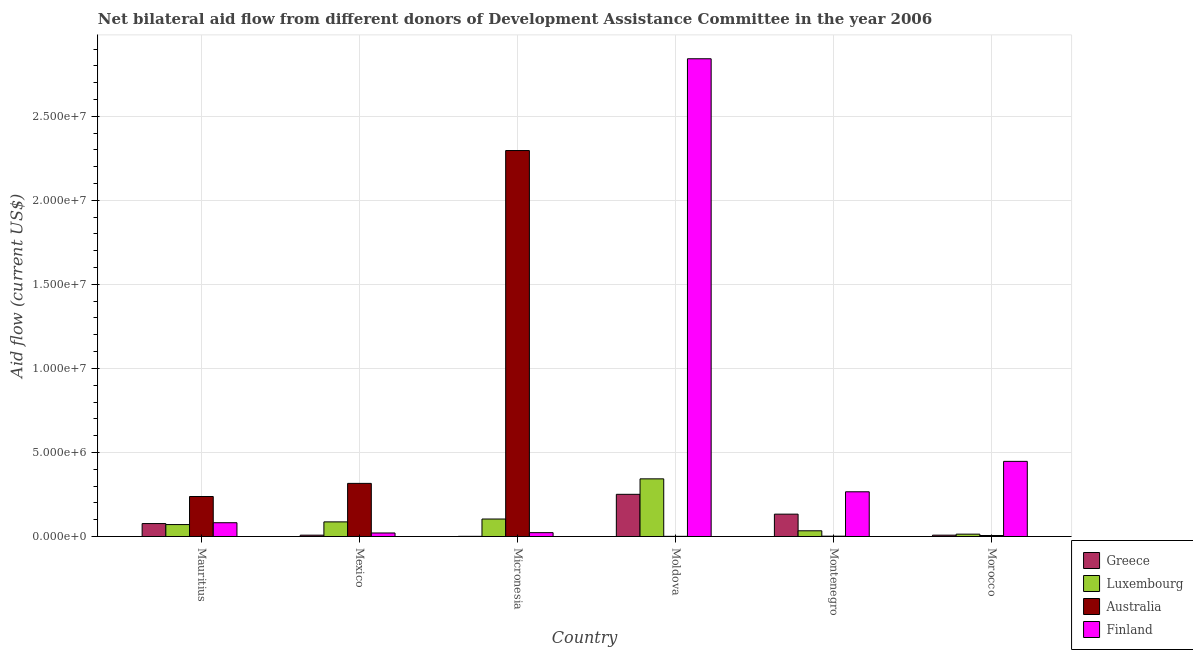How many bars are there on the 4th tick from the left?
Provide a succinct answer. 4. How many bars are there on the 6th tick from the right?
Keep it short and to the point. 4. What is the label of the 5th group of bars from the left?
Provide a short and direct response. Montenegro. In how many cases, is the number of bars for a given country not equal to the number of legend labels?
Give a very brief answer. 0. What is the amount of aid given by greece in Mexico?
Offer a very short reply. 8.00e+04. Across all countries, what is the maximum amount of aid given by luxembourg?
Provide a short and direct response. 3.43e+06. Across all countries, what is the minimum amount of aid given by finland?
Your answer should be very brief. 2.10e+05. In which country was the amount of aid given by luxembourg maximum?
Offer a terse response. Moldova. In which country was the amount of aid given by luxembourg minimum?
Offer a terse response. Morocco. What is the total amount of aid given by finland in the graph?
Your response must be concise. 3.68e+07. What is the difference between the amount of aid given by australia in Moldova and that in Montenegro?
Make the answer very short. -10000. What is the difference between the amount of aid given by finland in Morocco and the amount of aid given by australia in Mauritius?
Your answer should be very brief. 2.09e+06. What is the average amount of aid given by finland per country?
Provide a succinct answer. 6.14e+06. What is the difference between the amount of aid given by finland and amount of aid given by australia in Moldova?
Your answer should be compact. 2.84e+07. What is the ratio of the amount of aid given by luxembourg in Micronesia to that in Morocco?
Your answer should be compact. 7.43. What is the difference between the highest and the second highest amount of aid given by luxembourg?
Provide a succinct answer. 2.39e+06. What is the difference between the highest and the lowest amount of aid given by greece?
Provide a short and direct response. 2.50e+06. In how many countries, is the amount of aid given by finland greater than the average amount of aid given by finland taken over all countries?
Provide a short and direct response. 1. Is the sum of the amount of aid given by australia in Mauritius and Mexico greater than the maximum amount of aid given by greece across all countries?
Give a very brief answer. Yes. What does the 3rd bar from the right in Montenegro represents?
Your answer should be very brief. Luxembourg. Is it the case that in every country, the sum of the amount of aid given by greece and amount of aid given by luxembourg is greater than the amount of aid given by australia?
Offer a terse response. No. How many bars are there?
Your answer should be compact. 24. What is the difference between two consecutive major ticks on the Y-axis?
Your answer should be compact. 5.00e+06. How many legend labels are there?
Your answer should be very brief. 4. What is the title of the graph?
Ensure brevity in your answer.  Net bilateral aid flow from different donors of Development Assistance Committee in the year 2006. Does "Manufacturing" appear as one of the legend labels in the graph?
Offer a very short reply. No. What is the Aid flow (current US$) of Greece in Mauritius?
Offer a terse response. 7.70e+05. What is the Aid flow (current US$) of Luxembourg in Mauritius?
Provide a short and direct response. 7.10e+05. What is the Aid flow (current US$) in Australia in Mauritius?
Your answer should be compact. 2.38e+06. What is the Aid flow (current US$) of Finland in Mauritius?
Provide a succinct answer. 8.20e+05. What is the Aid flow (current US$) in Luxembourg in Mexico?
Offer a terse response. 8.70e+05. What is the Aid flow (current US$) of Australia in Mexico?
Offer a terse response. 3.16e+06. What is the Aid flow (current US$) of Greece in Micronesia?
Make the answer very short. 10000. What is the Aid flow (current US$) of Luxembourg in Micronesia?
Your answer should be compact. 1.04e+06. What is the Aid flow (current US$) of Australia in Micronesia?
Your answer should be very brief. 2.30e+07. What is the Aid flow (current US$) in Greece in Moldova?
Offer a terse response. 2.51e+06. What is the Aid flow (current US$) of Luxembourg in Moldova?
Keep it short and to the point. 3.43e+06. What is the Aid flow (current US$) of Finland in Moldova?
Give a very brief answer. 2.84e+07. What is the Aid flow (current US$) in Greece in Montenegro?
Ensure brevity in your answer.  1.33e+06. What is the Aid flow (current US$) in Finland in Montenegro?
Offer a terse response. 2.66e+06. What is the Aid flow (current US$) of Greece in Morocco?
Offer a terse response. 8.00e+04. What is the Aid flow (current US$) of Finland in Morocco?
Provide a short and direct response. 4.47e+06. Across all countries, what is the maximum Aid flow (current US$) of Greece?
Offer a terse response. 2.51e+06. Across all countries, what is the maximum Aid flow (current US$) of Luxembourg?
Keep it short and to the point. 3.43e+06. Across all countries, what is the maximum Aid flow (current US$) in Australia?
Ensure brevity in your answer.  2.30e+07. Across all countries, what is the maximum Aid flow (current US$) in Finland?
Your answer should be very brief. 2.84e+07. Across all countries, what is the minimum Aid flow (current US$) of Australia?
Your response must be concise. 10000. What is the total Aid flow (current US$) in Greece in the graph?
Make the answer very short. 4.78e+06. What is the total Aid flow (current US$) in Luxembourg in the graph?
Provide a succinct answer. 6.53e+06. What is the total Aid flow (current US$) of Australia in the graph?
Give a very brief answer. 2.86e+07. What is the total Aid flow (current US$) of Finland in the graph?
Offer a terse response. 3.68e+07. What is the difference between the Aid flow (current US$) of Greece in Mauritius and that in Mexico?
Your answer should be compact. 6.90e+05. What is the difference between the Aid flow (current US$) of Australia in Mauritius and that in Mexico?
Your answer should be very brief. -7.80e+05. What is the difference between the Aid flow (current US$) of Finland in Mauritius and that in Mexico?
Provide a short and direct response. 6.10e+05. What is the difference between the Aid flow (current US$) of Greece in Mauritius and that in Micronesia?
Provide a short and direct response. 7.60e+05. What is the difference between the Aid flow (current US$) of Luxembourg in Mauritius and that in Micronesia?
Your answer should be compact. -3.30e+05. What is the difference between the Aid flow (current US$) in Australia in Mauritius and that in Micronesia?
Ensure brevity in your answer.  -2.06e+07. What is the difference between the Aid flow (current US$) in Finland in Mauritius and that in Micronesia?
Offer a very short reply. 5.90e+05. What is the difference between the Aid flow (current US$) in Greece in Mauritius and that in Moldova?
Offer a very short reply. -1.74e+06. What is the difference between the Aid flow (current US$) of Luxembourg in Mauritius and that in Moldova?
Make the answer very short. -2.72e+06. What is the difference between the Aid flow (current US$) of Australia in Mauritius and that in Moldova?
Provide a short and direct response. 2.37e+06. What is the difference between the Aid flow (current US$) in Finland in Mauritius and that in Moldova?
Your response must be concise. -2.76e+07. What is the difference between the Aid flow (current US$) of Greece in Mauritius and that in Montenegro?
Your answer should be very brief. -5.60e+05. What is the difference between the Aid flow (current US$) in Luxembourg in Mauritius and that in Montenegro?
Your response must be concise. 3.70e+05. What is the difference between the Aid flow (current US$) in Australia in Mauritius and that in Montenegro?
Provide a short and direct response. 2.36e+06. What is the difference between the Aid flow (current US$) of Finland in Mauritius and that in Montenegro?
Keep it short and to the point. -1.84e+06. What is the difference between the Aid flow (current US$) in Greece in Mauritius and that in Morocco?
Provide a short and direct response. 6.90e+05. What is the difference between the Aid flow (current US$) in Luxembourg in Mauritius and that in Morocco?
Your answer should be compact. 5.70e+05. What is the difference between the Aid flow (current US$) in Australia in Mauritius and that in Morocco?
Offer a terse response. 2.32e+06. What is the difference between the Aid flow (current US$) of Finland in Mauritius and that in Morocco?
Offer a terse response. -3.65e+06. What is the difference between the Aid flow (current US$) in Luxembourg in Mexico and that in Micronesia?
Offer a terse response. -1.70e+05. What is the difference between the Aid flow (current US$) in Australia in Mexico and that in Micronesia?
Give a very brief answer. -1.98e+07. What is the difference between the Aid flow (current US$) of Finland in Mexico and that in Micronesia?
Your response must be concise. -2.00e+04. What is the difference between the Aid flow (current US$) of Greece in Mexico and that in Moldova?
Provide a succinct answer. -2.43e+06. What is the difference between the Aid flow (current US$) in Luxembourg in Mexico and that in Moldova?
Ensure brevity in your answer.  -2.56e+06. What is the difference between the Aid flow (current US$) in Australia in Mexico and that in Moldova?
Offer a very short reply. 3.15e+06. What is the difference between the Aid flow (current US$) of Finland in Mexico and that in Moldova?
Make the answer very short. -2.82e+07. What is the difference between the Aid flow (current US$) in Greece in Mexico and that in Montenegro?
Provide a succinct answer. -1.25e+06. What is the difference between the Aid flow (current US$) of Luxembourg in Mexico and that in Montenegro?
Your response must be concise. 5.30e+05. What is the difference between the Aid flow (current US$) in Australia in Mexico and that in Montenegro?
Provide a short and direct response. 3.14e+06. What is the difference between the Aid flow (current US$) in Finland in Mexico and that in Montenegro?
Ensure brevity in your answer.  -2.45e+06. What is the difference between the Aid flow (current US$) of Luxembourg in Mexico and that in Morocco?
Keep it short and to the point. 7.30e+05. What is the difference between the Aid flow (current US$) of Australia in Mexico and that in Morocco?
Offer a terse response. 3.10e+06. What is the difference between the Aid flow (current US$) of Finland in Mexico and that in Morocco?
Offer a terse response. -4.26e+06. What is the difference between the Aid flow (current US$) in Greece in Micronesia and that in Moldova?
Ensure brevity in your answer.  -2.50e+06. What is the difference between the Aid flow (current US$) of Luxembourg in Micronesia and that in Moldova?
Keep it short and to the point. -2.39e+06. What is the difference between the Aid flow (current US$) of Australia in Micronesia and that in Moldova?
Offer a very short reply. 2.30e+07. What is the difference between the Aid flow (current US$) in Finland in Micronesia and that in Moldova?
Ensure brevity in your answer.  -2.82e+07. What is the difference between the Aid flow (current US$) of Greece in Micronesia and that in Montenegro?
Make the answer very short. -1.32e+06. What is the difference between the Aid flow (current US$) of Australia in Micronesia and that in Montenegro?
Offer a very short reply. 2.29e+07. What is the difference between the Aid flow (current US$) in Finland in Micronesia and that in Montenegro?
Ensure brevity in your answer.  -2.43e+06. What is the difference between the Aid flow (current US$) of Greece in Micronesia and that in Morocco?
Keep it short and to the point. -7.00e+04. What is the difference between the Aid flow (current US$) of Australia in Micronesia and that in Morocco?
Your response must be concise. 2.29e+07. What is the difference between the Aid flow (current US$) of Finland in Micronesia and that in Morocco?
Give a very brief answer. -4.24e+06. What is the difference between the Aid flow (current US$) in Greece in Moldova and that in Montenegro?
Keep it short and to the point. 1.18e+06. What is the difference between the Aid flow (current US$) of Luxembourg in Moldova and that in Montenegro?
Your answer should be compact. 3.09e+06. What is the difference between the Aid flow (current US$) in Australia in Moldova and that in Montenegro?
Offer a very short reply. -10000. What is the difference between the Aid flow (current US$) of Finland in Moldova and that in Montenegro?
Ensure brevity in your answer.  2.58e+07. What is the difference between the Aid flow (current US$) of Greece in Moldova and that in Morocco?
Give a very brief answer. 2.43e+06. What is the difference between the Aid flow (current US$) of Luxembourg in Moldova and that in Morocco?
Give a very brief answer. 3.29e+06. What is the difference between the Aid flow (current US$) in Finland in Moldova and that in Morocco?
Provide a short and direct response. 2.40e+07. What is the difference between the Aid flow (current US$) in Greece in Montenegro and that in Morocco?
Your answer should be very brief. 1.25e+06. What is the difference between the Aid flow (current US$) of Luxembourg in Montenegro and that in Morocco?
Give a very brief answer. 2.00e+05. What is the difference between the Aid flow (current US$) of Finland in Montenegro and that in Morocco?
Offer a very short reply. -1.81e+06. What is the difference between the Aid flow (current US$) of Greece in Mauritius and the Aid flow (current US$) of Australia in Mexico?
Give a very brief answer. -2.39e+06. What is the difference between the Aid flow (current US$) in Greece in Mauritius and the Aid flow (current US$) in Finland in Mexico?
Your answer should be compact. 5.60e+05. What is the difference between the Aid flow (current US$) in Luxembourg in Mauritius and the Aid flow (current US$) in Australia in Mexico?
Your answer should be compact. -2.45e+06. What is the difference between the Aid flow (current US$) in Australia in Mauritius and the Aid flow (current US$) in Finland in Mexico?
Your answer should be very brief. 2.17e+06. What is the difference between the Aid flow (current US$) in Greece in Mauritius and the Aid flow (current US$) in Australia in Micronesia?
Your response must be concise. -2.22e+07. What is the difference between the Aid flow (current US$) in Greece in Mauritius and the Aid flow (current US$) in Finland in Micronesia?
Provide a short and direct response. 5.40e+05. What is the difference between the Aid flow (current US$) of Luxembourg in Mauritius and the Aid flow (current US$) of Australia in Micronesia?
Offer a very short reply. -2.22e+07. What is the difference between the Aid flow (current US$) of Luxembourg in Mauritius and the Aid flow (current US$) of Finland in Micronesia?
Offer a very short reply. 4.80e+05. What is the difference between the Aid flow (current US$) of Australia in Mauritius and the Aid flow (current US$) of Finland in Micronesia?
Give a very brief answer. 2.15e+06. What is the difference between the Aid flow (current US$) in Greece in Mauritius and the Aid flow (current US$) in Luxembourg in Moldova?
Ensure brevity in your answer.  -2.66e+06. What is the difference between the Aid flow (current US$) in Greece in Mauritius and the Aid flow (current US$) in Australia in Moldova?
Ensure brevity in your answer.  7.60e+05. What is the difference between the Aid flow (current US$) in Greece in Mauritius and the Aid flow (current US$) in Finland in Moldova?
Offer a very short reply. -2.76e+07. What is the difference between the Aid flow (current US$) of Luxembourg in Mauritius and the Aid flow (current US$) of Finland in Moldova?
Provide a succinct answer. -2.77e+07. What is the difference between the Aid flow (current US$) of Australia in Mauritius and the Aid flow (current US$) of Finland in Moldova?
Offer a very short reply. -2.60e+07. What is the difference between the Aid flow (current US$) of Greece in Mauritius and the Aid flow (current US$) of Australia in Montenegro?
Ensure brevity in your answer.  7.50e+05. What is the difference between the Aid flow (current US$) of Greece in Mauritius and the Aid flow (current US$) of Finland in Montenegro?
Ensure brevity in your answer.  -1.89e+06. What is the difference between the Aid flow (current US$) of Luxembourg in Mauritius and the Aid flow (current US$) of Australia in Montenegro?
Your answer should be compact. 6.90e+05. What is the difference between the Aid flow (current US$) of Luxembourg in Mauritius and the Aid flow (current US$) of Finland in Montenegro?
Provide a succinct answer. -1.95e+06. What is the difference between the Aid flow (current US$) in Australia in Mauritius and the Aid flow (current US$) in Finland in Montenegro?
Give a very brief answer. -2.80e+05. What is the difference between the Aid flow (current US$) of Greece in Mauritius and the Aid flow (current US$) of Luxembourg in Morocco?
Your response must be concise. 6.30e+05. What is the difference between the Aid flow (current US$) of Greece in Mauritius and the Aid flow (current US$) of Australia in Morocco?
Offer a terse response. 7.10e+05. What is the difference between the Aid flow (current US$) of Greece in Mauritius and the Aid flow (current US$) of Finland in Morocco?
Your answer should be compact. -3.70e+06. What is the difference between the Aid flow (current US$) of Luxembourg in Mauritius and the Aid flow (current US$) of Australia in Morocco?
Provide a short and direct response. 6.50e+05. What is the difference between the Aid flow (current US$) in Luxembourg in Mauritius and the Aid flow (current US$) in Finland in Morocco?
Provide a succinct answer. -3.76e+06. What is the difference between the Aid flow (current US$) of Australia in Mauritius and the Aid flow (current US$) of Finland in Morocco?
Offer a very short reply. -2.09e+06. What is the difference between the Aid flow (current US$) in Greece in Mexico and the Aid flow (current US$) in Luxembourg in Micronesia?
Your answer should be compact. -9.60e+05. What is the difference between the Aid flow (current US$) of Greece in Mexico and the Aid flow (current US$) of Australia in Micronesia?
Keep it short and to the point. -2.29e+07. What is the difference between the Aid flow (current US$) in Luxembourg in Mexico and the Aid flow (current US$) in Australia in Micronesia?
Your answer should be compact. -2.21e+07. What is the difference between the Aid flow (current US$) in Luxembourg in Mexico and the Aid flow (current US$) in Finland in Micronesia?
Offer a terse response. 6.40e+05. What is the difference between the Aid flow (current US$) in Australia in Mexico and the Aid flow (current US$) in Finland in Micronesia?
Offer a terse response. 2.93e+06. What is the difference between the Aid flow (current US$) in Greece in Mexico and the Aid flow (current US$) in Luxembourg in Moldova?
Provide a succinct answer. -3.35e+06. What is the difference between the Aid flow (current US$) in Greece in Mexico and the Aid flow (current US$) in Australia in Moldova?
Provide a short and direct response. 7.00e+04. What is the difference between the Aid flow (current US$) of Greece in Mexico and the Aid flow (current US$) of Finland in Moldova?
Ensure brevity in your answer.  -2.83e+07. What is the difference between the Aid flow (current US$) of Luxembourg in Mexico and the Aid flow (current US$) of Australia in Moldova?
Your answer should be compact. 8.60e+05. What is the difference between the Aid flow (current US$) of Luxembourg in Mexico and the Aid flow (current US$) of Finland in Moldova?
Make the answer very short. -2.76e+07. What is the difference between the Aid flow (current US$) of Australia in Mexico and the Aid flow (current US$) of Finland in Moldova?
Make the answer very short. -2.53e+07. What is the difference between the Aid flow (current US$) of Greece in Mexico and the Aid flow (current US$) of Australia in Montenegro?
Your answer should be compact. 6.00e+04. What is the difference between the Aid flow (current US$) of Greece in Mexico and the Aid flow (current US$) of Finland in Montenegro?
Give a very brief answer. -2.58e+06. What is the difference between the Aid flow (current US$) in Luxembourg in Mexico and the Aid flow (current US$) in Australia in Montenegro?
Give a very brief answer. 8.50e+05. What is the difference between the Aid flow (current US$) in Luxembourg in Mexico and the Aid flow (current US$) in Finland in Montenegro?
Keep it short and to the point. -1.79e+06. What is the difference between the Aid flow (current US$) of Australia in Mexico and the Aid flow (current US$) of Finland in Montenegro?
Your response must be concise. 5.00e+05. What is the difference between the Aid flow (current US$) in Greece in Mexico and the Aid flow (current US$) in Luxembourg in Morocco?
Your answer should be compact. -6.00e+04. What is the difference between the Aid flow (current US$) of Greece in Mexico and the Aid flow (current US$) of Finland in Morocco?
Offer a terse response. -4.39e+06. What is the difference between the Aid flow (current US$) of Luxembourg in Mexico and the Aid flow (current US$) of Australia in Morocco?
Your answer should be compact. 8.10e+05. What is the difference between the Aid flow (current US$) of Luxembourg in Mexico and the Aid flow (current US$) of Finland in Morocco?
Make the answer very short. -3.60e+06. What is the difference between the Aid flow (current US$) in Australia in Mexico and the Aid flow (current US$) in Finland in Morocco?
Offer a very short reply. -1.31e+06. What is the difference between the Aid flow (current US$) in Greece in Micronesia and the Aid flow (current US$) in Luxembourg in Moldova?
Your answer should be very brief. -3.42e+06. What is the difference between the Aid flow (current US$) of Greece in Micronesia and the Aid flow (current US$) of Australia in Moldova?
Your response must be concise. 0. What is the difference between the Aid flow (current US$) in Greece in Micronesia and the Aid flow (current US$) in Finland in Moldova?
Give a very brief answer. -2.84e+07. What is the difference between the Aid flow (current US$) of Luxembourg in Micronesia and the Aid flow (current US$) of Australia in Moldova?
Your answer should be compact. 1.03e+06. What is the difference between the Aid flow (current US$) of Luxembourg in Micronesia and the Aid flow (current US$) of Finland in Moldova?
Provide a short and direct response. -2.74e+07. What is the difference between the Aid flow (current US$) of Australia in Micronesia and the Aid flow (current US$) of Finland in Moldova?
Provide a succinct answer. -5.46e+06. What is the difference between the Aid flow (current US$) in Greece in Micronesia and the Aid flow (current US$) in Luxembourg in Montenegro?
Provide a short and direct response. -3.30e+05. What is the difference between the Aid flow (current US$) in Greece in Micronesia and the Aid flow (current US$) in Australia in Montenegro?
Your answer should be compact. -10000. What is the difference between the Aid flow (current US$) of Greece in Micronesia and the Aid flow (current US$) of Finland in Montenegro?
Provide a succinct answer. -2.65e+06. What is the difference between the Aid flow (current US$) of Luxembourg in Micronesia and the Aid flow (current US$) of Australia in Montenegro?
Make the answer very short. 1.02e+06. What is the difference between the Aid flow (current US$) in Luxembourg in Micronesia and the Aid flow (current US$) in Finland in Montenegro?
Make the answer very short. -1.62e+06. What is the difference between the Aid flow (current US$) in Australia in Micronesia and the Aid flow (current US$) in Finland in Montenegro?
Your answer should be very brief. 2.03e+07. What is the difference between the Aid flow (current US$) in Greece in Micronesia and the Aid flow (current US$) in Australia in Morocco?
Your answer should be compact. -5.00e+04. What is the difference between the Aid flow (current US$) in Greece in Micronesia and the Aid flow (current US$) in Finland in Morocco?
Ensure brevity in your answer.  -4.46e+06. What is the difference between the Aid flow (current US$) of Luxembourg in Micronesia and the Aid flow (current US$) of Australia in Morocco?
Provide a succinct answer. 9.80e+05. What is the difference between the Aid flow (current US$) of Luxembourg in Micronesia and the Aid flow (current US$) of Finland in Morocco?
Make the answer very short. -3.43e+06. What is the difference between the Aid flow (current US$) of Australia in Micronesia and the Aid flow (current US$) of Finland in Morocco?
Offer a very short reply. 1.85e+07. What is the difference between the Aid flow (current US$) in Greece in Moldova and the Aid flow (current US$) in Luxembourg in Montenegro?
Provide a short and direct response. 2.17e+06. What is the difference between the Aid flow (current US$) in Greece in Moldova and the Aid flow (current US$) in Australia in Montenegro?
Provide a succinct answer. 2.49e+06. What is the difference between the Aid flow (current US$) in Greece in Moldova and the Aid flow (current US$) in Finland in Montenegro?
Offer a terse response. -1.50e+05. What is the difference between the Aid flow (current US$) of Luxembourg in Moldova and the Aid flow (current US$) of Australia in Montenegro?
Keep it short and to the point. 3.41e+06. What is the difference between the Aid flow (current US$) of Luxembourg in Moldova and the Aid flow (current US$) of Finland in Montenegro?
Offer a terse response. 7.70e+05. What is the difference between the Aid flow (current US$) in Australia in Moldova and the Aid flow (current US$) in Finland in Montenegro?
Provide a short and direct response. -2.65e+06. What is the difference between the Aid flow (current US$) in Greece in Moldova and the Aid flow (current US$) in Luxembourg in Morocco?
Provide a succinct answer. 2.37e+06. What is the difference between the Aid flow (current US$) in Greece in Moldova and the Aid flow (current US$) in Australia in Morocco?
Offer a terse response. 2.45e+06. What is the difference between the Aid flow (current US$) in Greece in Moldova and the Aid flow (current US$) in Finland in Morocco?
Give a very brief answer. -1.96e+06. What is the difference between the Aid flow (current US$) in Luxembourg in Moldova and the Aid flow (current US$) in Australia in Morocco?
Your answer should be compact. 3.37e+06. What is the difference between the Aid flow (current US$) of Luxembourg in Moldova and the Aid flow (current US$) of Finland in Morocco?
Keep it short and to the point. -1.04e+06. What is the difference between the Aid flow (current US$) of Australia in Moldova and the Aid flow (current US$) of Finland in Morocco?
Provide a short and direct response. -4.46e+06. What is the difference between the Aid flow (current US$) of Greece in Montenegro and the Aid flow (current US$) of Luxembourg in Morocco?
Ensure brevity in your answer.  1.19e+06. What is the difference between the Aid flow (current US$) in Greece in Montenegro and the Aid flow (current US$) in Australia in Morocco?
Your answer should be very brief. 1.27e+06. What is the difference between the Aid flow (current US$) of Greece in Montenegro and the Aid flow (current US$) of Finland in Morocco?
Offer a very short reply. -3.14e+06. What is the difference between the Aid flow (current US$) of Luxembourg in Montenegro and the Aid flow (current US$) of Finland in Morocco?
Your response must be concise. -4.13e+06. What is the difference between the Aid flow (current US$) in Australia in Montenegro and the Aid flow (current US$) in Finland in Morocco?
Ensure brevity in your answer.  -4.45e+06. What is the average Aid flow (current US$) of Greece per country?
Provide a short and direct response. 7.97e+05. What is the average Aid flow (current US$) in Luxembourg per country?
Provide a succinct answer. 1.09e+06. What is the average Aid flow (current US$) of Australia per country?
Ensure brevity in your answer.  4.76e+06. What is the average Aid flow (current US$) in Finland per country?
Make the answer very short. 6.14e+06. What is the difference between the Aid flow (current US$) of Greece and Aid flow (current US$) of Luxembourg in Mauritius?
Your response must be concise. 6.00e+04. What is the difference between the Aid flow (current US$) in Greece and Aid flow (current US$) in Australia in Mauritius?
Give a very brief answer. -1.61e+06. What is the difference between the Aid flow (current US$) in Greece and Aid flow (current US$) in Finland in Mauritius?
Ensure brevity in your answer.  -5.00e+04. What is the difference between the Aid flow (current US$) of Luxembourg and Aid flow (current US$) of Australia in Mauritius?
Keep it short and to the point. -1.67e+06. What is the difference between the Aid flow (current US$) of Luxembourg and Aid flow (current US$) of Finland in Mauritius?
Provide a short and direct response. -1.10e+05. What is the difference between the Aid flow (current US$) of Australia and Aid flow (current US$) of Finland in Mauritius?
Provide a succinct answer. 1.56e+06. What is the difference between the Aid flow (current US$) in Greece and Aid flow (current US$) in Luxembourg in Mexico?
Provide a short and direct response. -7.90e+05. What is the difference between the Aid flow (current US$) in Greece and Aid flow (current US$) in Australia in Mexico?
Keep it short and to the point. -3.08e+06. What is the difference between the Aid flow (current US$) of Luxembourg and Aid flow (current US$) of Australia in Mexico?
Your response must be concise. -2.29e+06. What is the difference between the Aid flow (current US$) in Australia and Aid flow (current US$) in Finland in Mexico?
Make the answer very short. 2.95e+06. What is the difference between the Aid flow (current US$) in Greece and Aid flow (current US$) in Luxembourg in Micronesia?
Provide a short and direct response. -1.03e+06. What is the difference between the Aid flow (current US$) in Greece and Aid flow (current US$) in Australia in Micronesia?
Offer a terse response. -2.30e+07. What is the difference between the Aid flow (current US$) in Luxembourg and Aid flow (current US$) in Australia in Micronesia?
Your answer should be very brief. -2.19e+07. What is the difference between the Aid flow (current US$) in Luxembourg and Aid flow (current US$) in Finland in Micronesia?
Your answer should be very brief. 8.10e+05. What is the difference between the Aid flow (current US$) in Australia and Aid flow (current US$) in Finland in Micronesia?
Provide a short and direct response. 2.27e+07. What is the difference between the Aid flow (current US$) of Greece and Aid flow (current US$) of Luxembourg in Moldova?
Offer a terse response. -9.20e+05. What is the difference between the Aid flow (current US$) in Greece and Aid flow (current US$) in Australia in Moldova?
Offer a terse response. 2.50e+06. What is the difference between the Aid flow (current US$) in Greece and Aid flow (current US$) in Finland in Moldova?
Your response must be concise. -2.59e+07. What is the difference between the Aid flow (current US$) of Luxembourg and Aid flow (current US$) of Australia in Moldova?
Give a very brief answer. 3.42e+06. What is the difference between the Aid flow (current US$) of Luxembourg and Aid flow (current US$) of Finland in Moldova?
Provide a short and direct response. -2.50e+07. What is the difference between the Aid flow (current US$) of Australia and Aid flow (current US$) of Finland in Moldova?
Your response must be concise. -2.84e+07. What is the difference between the Aid flow (current US$) in Greece and Aid flow (current US$) in Luxembourg in Montenegro?
Provide a succinct answer. 9.90e+05. What is the difference between the Aid flow (current US$) of Greece and Aid flow (current US$) of Australia in Montenegro?
Your response must be concise. 1.31e+06. What is the difference between the Aid flow (current US$) in Greece and Aid flow (current US$) in Finland in Montenegro?
Provide a short and direct response. -1.33e+06. What is the difference between the Aid flow (current US$) in Luxembourg and Aid flow (current US$) in Finland in Montenegro?
Ensure brevity in your answer.  -2.32e+06. What is the difference between the Aid flow (current US$) of Australia and Aid flow (current US$) of Finland in Montenegro?
Make the answer very short. -2.64e+06. What is the difference between the Aid flow (current US$) in Greece and Aid flow (current US$) in Luxembourg in Morocco?
Your answer should be very brief. -6.00e+04. What is the difference between the Aid flow (current US$) of Greece and Aid flow (current US$) of Finland in Morocco?
Your answer should be very brief. -4.39e+06. What is the difference between the Aid flow (current US$) of Luxembourg and Aid flow (current US$) of Finland in Morocco?
Offer a very short reply. -4.33e+06. What is the difference between the Aid flow (current US$) of Australia and Aid flow (current US$) of Finland in Morocco?
Offer a very short reply. -4.41e+06. What is the ratio of the Aid flow (current US$) of Greece in Mauritius to that in Mexico?
Offer a terse response. 9.62. What is the ratio of the Aid flow (current US$) in Luxembourg in Mauritius to that in Mexico?
Ensure brevity in your answer.  0.82. What is the ratio of the Aid flow (current US$) in Australia in Mauritius to that in Mexico?
Your answer should be compact. 0.75. What is the ratio of the Aid flow (current US$) of Finland in Mauritius to that in Mexico?
Give a very brief answer. 3.9. What is the ratio of the Aid flow (current US$) of Greece in Mauritius to that in Micronesia?
Your answer should be very brief. 77. What is the ratio of the Aid flow (current US$) of Luxembourg in Mauritius to that in Micronesia?
Give a very brief answer. 0.68. What is the ratio of the Aid flow (current US$) of Australia in Mauritius to that in Micronesia?
Your answer should be compact. 0.1. What is the ratio of the Aid flow (current US$) in Finland in Mauritius to that in Micronesia?
Your response must be concise. 3.57. What is the ratio of the Aid flow (current US$) in Greece in Mauritius to that in Moldova?
Give a very brief answer. 0.31. What is the ratio of the Aid flow (current US$) of Luxembourg in Mauritius to that in Moldova?
Ensure brevity in your answer.  0.21. What is the ratio of the Aid flow (current US$) of Australia in Mauritius to that in Moldova?
Make the answer very short. 238. What is the ratio of the Aid flow (current US$) in Finland in Mauritius to that in Moldova?
Make the answer very short. 0.03. What is the ratio of the Aid flow (current US$) of Greece in Mauritius to that in Montenegro?
Ensure brevity in your answer.  0.58. What is the ratio of the Aid flow (current US$) of Luxembourg in Mauritius to that in Montenegro?
Provide a short and direct response. 2.09. What is the ratio of the Aid flow (current US$) in Australia in Mauritius to that in Montenegro?
Your answer should be compact. 119. What is the ratio of the Aid flow (current US$) of Finland in Mauritius to that in Montenegro?
Offer a very short reply. 0.31. What is the ratio of the Aid flow (current US$) in Greece in Mauritius to that in Morocco?
Your answer should be compact. 9.62. What is the ratio of the Aid flow (current US$) in Luxembourg in Mauritius to that in Morocco?
Ensure brevity in your answer.  5.07. What is the ratio of the Aid flow (current US$) in Australia in Mauritius to that in Morocco?
Provide a succinct answer. 39.67. What is the ratio of the Aid flow (current US$) in Finland in Mauritius to that in Morocco?
Your answer should be very brief. 0.18. What is the ratio of the Aid flow (current US$) of Luxembourg in Mexico to that in Micronesia?
Offer a terse response. 0.84. What is the ratio of the Aid flow (current US$) in Australia in Mexico to that in Micronesia?
Offer a very short reply. 0.14. What is the ratio of the Aid flow (current US$) in Greece in Mexico to that in Moldova?
Offer a terse response. 0.03. What is the ratio of the Aid flow (current US$) of Luxembourg in Mexico to that in Moldova?
Offer a terse response. 0.25. What is the ratio of the Aid flow (current US$) of Australia in Mexico to that in Moldova?
Your answer should be compact. 316. What is the ratio of the Aid flow (current US$) in Finland in Mexico to that in Moldova?
Your response must be concise. 0.01. What is the ratio of the Aid flow (current US$) in Greece in Mexico to that in Montenegro?
Make the answer very short. 0.06. What is the ratio of the Aid flow (current US$) in Luxembourg in Mexico to that in Montenegro?
Your response must be concise. 2.56. What is the ratio of the Aid flow (current US$) of Australia in Mexico to that in Montenegro?
Make the answer very short. 158. What is the ratio of the Aid flow (current US$) of Finland in Mexico to that in Montenegro?
Ensure brevity in your answer.  0.08. What is the ratio of the Aid flow (current US$) of Luxembourg in Mexico to that in Morocco?
Offer a very short reply. 6.21. What is the ratio of the Aid flow (current US$) of Australia in Mexico to that in Morocco?
Give a very brief answer. 52.67. What is the ratio of the Aid flow (current US$) in Finland in Mexico to that in Morocco?
Provide a short and direct response. 0.05. What is the ratio of the Aid flow (current US$) in Greece in Micronesia to that in Moldova?
Provide a succinct answer. 0. What is the ratio of the Aid flow (current US$) in Luxembourg in Micronesia to that in Moldova?
Ensure brevity in your answer.  0.3. What is the ratio of the Aid flow (current US$) in Australia in Micronesia to that in Moldova?
Make the answer very short. 2296. What is the ratio of the Aid flow (current US$) of Finland in Micronesia to that in Moldova?
Your answer should be very brief. 0.01. What is the ratio of the Aid flow (current US$) in Greece in Micronesia to that in Montenegro?
Your response must be concise. 0.01. What is the ratio of the Aid flow (current US$) in Luxembourg in Micronesia to that in Montenegro?
Offer a terse response. 3.06. What is the ratio of the Aid flow (current US$) in Australia in Micronesia to that in Montenegro?
Your answer should be compact. 1148. What is the ratio of the Aid flow (current US$) of Finland in Micronesia to that in Montenegro?
Your answer should be very brief. 0.09. What is the ratio of the Aid flow (current US$) of Luxembourg in Micronesia to that in Morocco?
Give a very brief answer. 7.43. What is the ratio of the Aid flow (current US$) of Australia in Micronesia to that in Morocco?
Provide a short and direct response. 382.67. What is the ratio of the Aid flow (current US$) of Finland in Micronesia to that in Morocco?
Provide a succinct answer. 0.05. What is the ratio of the Aid flow (current US$) in Greece in Moldova to that in Montenegro?
Ensure brevity in your answer.  1.89. What is the ratio of the Aid flow (current US$) in Luxembourg in Moldova to that in Montenegro?
Offer a terse response. 10.09. What is the ratio of the Aid flow (current US$) of Australia in Moldova to that in Montenegro?
Provide a short and direct response. 0.5. What is the ratio of the Aid flow (current US$) of Finland in Moldova to that in Montenegro?
Provide a short and direct response. 10.68. What is the ratio of the Aid flow (current US$) of Greece in Moldova to that in Morocco?
Ensure brevity in your answer.  31.38. What is the ratio of the Aid flow (current US$) of Finland in Moldova to that in Morocco?
Ensure brevity in your answer.  6.36. What is the ratio of the Aid flow (current US$) of Greece in Montenegro to that in Morocco?
Your response must be concise. 16.62. What is the ratio of the Aid flow (current US$) in Luxembourg in Montenegro to that in Morocco?
Your answer should be compact. 2.43. What is the ratio of the Aid flow (current US$) in Finland in Montenegro to that in Morocco?
Ensure brevity in your answer.  0.6. What is the difference between the highest and the second highest Aid flow (current US$) of Greece?
Provide a succinct answer. 1.18e+06. What is the difference between the highest and the second highest Aid flow (current US$) in Luxembourg?
Provide a succinct answer. 2.39e+06. What is the difference between the highest and the second highest Aid flow (current US$) in Australia?
Keep it short and to the point. 1.98e+07. What is the difference between the highest and the second highest Aid flow (current US$) in Finland?
Make the answer very short. 2.40e+07. What is the difference between the highest and the lowest Aid flow (current US$) in Greece?
Your answer should be very brief. 2.50e+06. What is the difference between the highest and the lowest Aid flow (current US$) in Luxembourg?
Your response must be concise. 3.29e+06. What is the difference between the highest and the lowest Aid flow (current US$) of Australia?
Make the answer very short. 2.30e+07. What is the difference between the highest and the lowest Aid flow (current US$) of Finland?
Provide a succinct answer. 2.82e+07. 